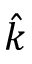<formula> <loc_0><loc_0><loc_500><loc_500>\hat { k }</formula> 